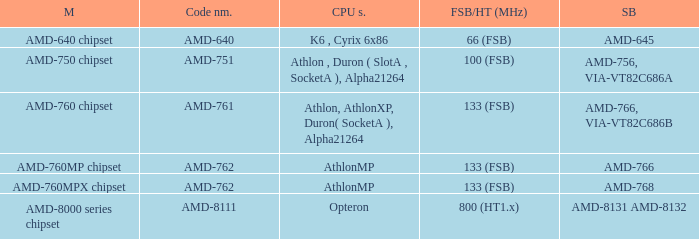What is the FSB / HT (MHz) when the Southbridge is amd-8131 amd-8132? 800 (HT1.x). 